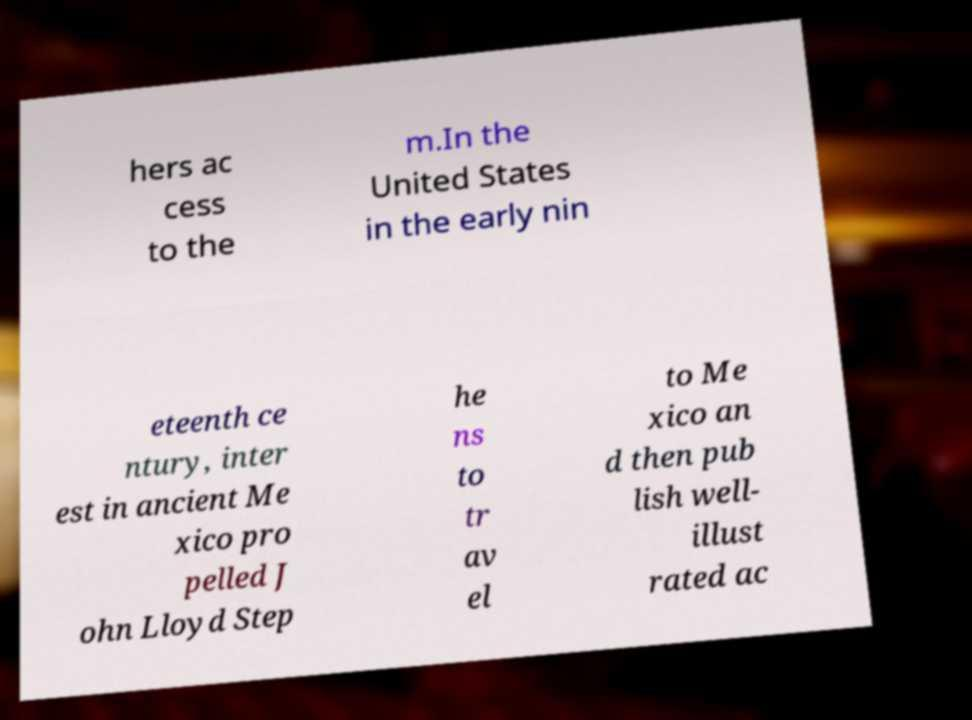What messages or text are displayed in this image? I need them in a readable, typed format. hers ac cess to the m.In the United States in the early nin eteenth ce ntury, inter est in ancient Me xico pro pelled J ohn Lloyd Step he ns to tr av el to Me xico an d then pub lish well- illust rated ac 